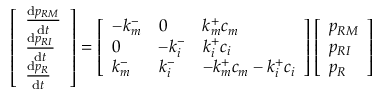<formula> <loc_0><loc_0><loc_500><loc_500>\left [ \begin{array} { l } { \frac { d p _ { R M } } { d t } } \\ { \frac { d p _ { R I } } { d t } } \\ { \frac { d p _ { R } } { d t } } \end{array} \right ] = \left [ \begin{array} { l l l } { - k _ { m } ^ { - } } & { 0 } & { k _ { m } ^ { + } c _ { m } } \\ { 0 } & { - k _ { i } ^ { - } } & { k _ { i } ^ { + } c _ { i } } \\ { k _ { m } ^ { - } } & { k _ { i } ^ { - } } & { - k _ { m } ^ { + } c _ { m } - k _ { i } ^ { + } c _ { i } } \end{array} \right ] \left [ \begin{array} { l } { p _ { R M } } \\ { p _ { R I } } \\ { p _ { R } } \end{array} \right ]</formula> 